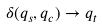<formula> <loc_0><loc_0><loc_500><loc_500>\delta ( q _ { s } , q _ { c } ) \rightarrow q _ { t }</formula> 